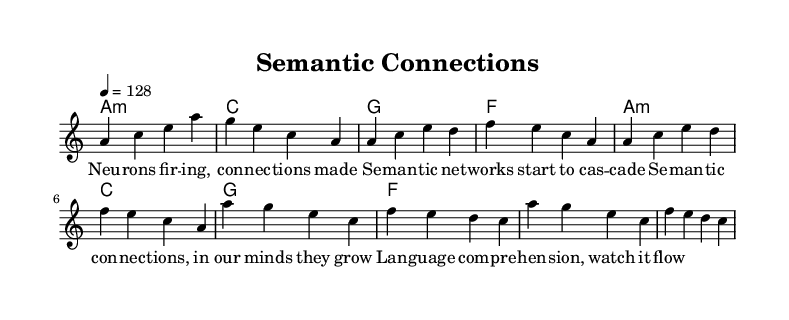What is the key signature of this music? The key signature is A minor, which is indicated by the presence of no sharps or flats in the key signature section of the sheet music.
Answer: A minor What is the time signature of this music? The time signature is 4/4, which is indicated near the beginning of the score. It specifies that there are four beats per measure and that the quarter note gets one beat.
Answer: 4/4 What is the tempo indication for this piece? The tempo is indicated as 4 = 128, which means the music should be played at a speed of 128 beats per minute. This is typically a moderate to fast tempo suitable for house music.
Answer: 128 How many measures are in the chorus? The chorus consists of 4 measures, as visualized in the melody section with the repetition of the same melody and lyrics. Each set of lyrics corresponds to one measure.
Answer: 4 What is the primary theme of the lyrics in this anthem? The primary theme of the lyrics revolves around semantic connections and language comprehension, as evident from the wording used in both the verse and chorus sections. This reflects the cognitive linguistics focus of the music.
Answer: Semantic connections What type of chords are used in the harmony section? The harmony section primarily uses minor and major chords, specifically A minor, C major, G major, and F major. These chords create a typical harmonic structure commonly found in house music.
Answer: Minor and major chords What does the term "cas-cade" suggest about the nature of semantic networks? The term "cascade" implies that semantic networks can develop and grow dynamically, much like the way neural connections strengthen and create a flow of language comprehension in the mind.
Answer: Dynamic development 